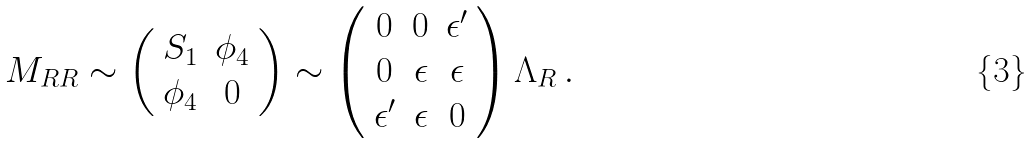Convert formula to latex. <formula><loc_0><loc_0><loc_500><loc_500>M _ { R R } \sim \left ( \begin{array} { c c } S _ { 1 } & \phi _ { 4 } \\ \phi _ { 4 } & 0 \end{array} \right ) \sim \left ( \begin{array} { c c c } 0 & 0 & \epsilon ^ { \prime } \\ 0 & \epsilon & \epsilon \\ \epsilon ^ { \prime } & \epsilon & 0 \end{array} \right ) \Lambda _ { R } \, .</formula> 